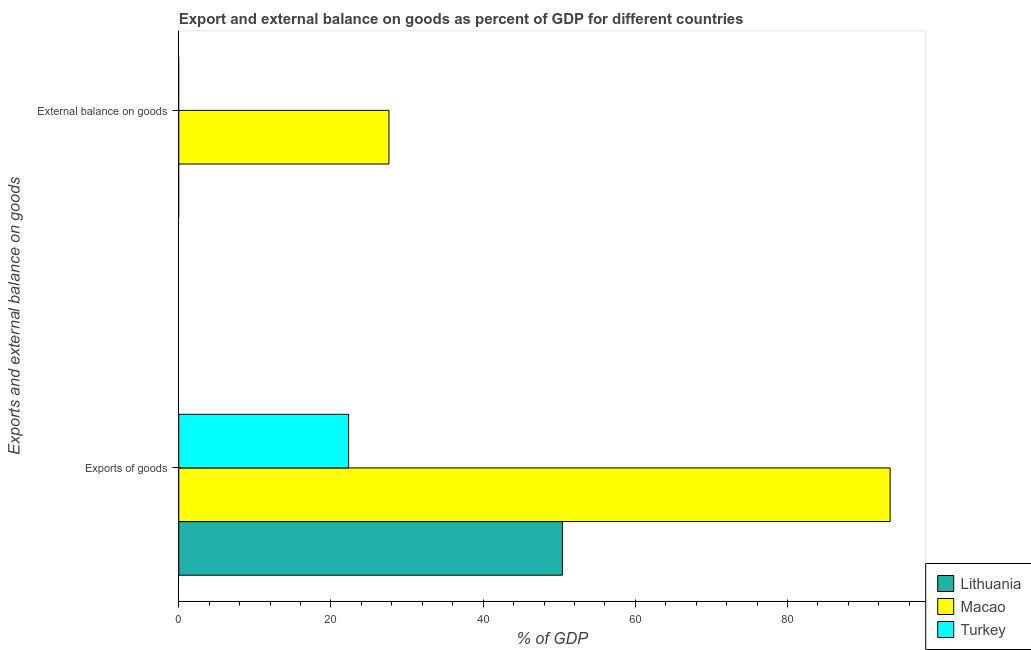Are the number of bars on each tick of the Y-axis equal?
Provide a succinct answer. No. How many bars are there on the 2nd tick from the bottom?
Provide a short and direct response. 1. What is the label of the 1st group of bars from the top?
Your answer should be very brief. External balance on goods. What is the external balance on goods as percentage of gdp in Turkey?
Offer a terse response. 0. Across all countries, what is the maximum export of goods as percentage of gdp?
Keep it short and to the point. 93.49. In which country was the export of goods as percentage of gdp maximum?
Your answer should be very brief. Macao. What is the total external balance on goods as percentage of gdp in the graph?
Offer a terse response. 27.62. What is the difference between the export of goods as percentage of gdp in Macao and that in Lithuania?
Keep it short and to the point. 43.07. What is the difference between the external balance on goods as percentage of gdp in Macao and the export of goods as percentage of gdp in Lithuania?
Give a very brief answer. -22.8. What is the average external balance on goods as percentage of gdp per country?
Your answer should be compact. 9.21. What is the difference between the export of goods as percentage of gdp and external balance on goods as percentage of gdp in Macao?
Make the answer very short. 65.87. What is the ratio of the export of goods as percentage of gdp in Turkey to that in Macao?
Give a very brief answer. 0.24. Are all the bars in the graph horizontal?
Your answer should be compact. Yes. How many countries are there in the graph?
Make the answer very short. 3. Are the values on the major ticks of X-axis written in scientific E-notation?
Offer a very short reply. No. Does the graph contain any zero values?
Keep it short and to the point. Yes. Where does the legend appear in the graph?
Provide a short and direct response. Bottom right. How are the legend labels stacked?
Make the answer very short. Vertical. What is the title of the graph?
Keep it short and to the point. Export and external balance on goods as percent of GDP for different countries. Does "Guinea" appear as one of the legend labels in the graph?
Provide a short and direct response. No. What is the label or title of the X-axis?
Provide a succinct answer. % of GDP. What is the label or title of the Y-axis?
Make the answer very short. Exports and external balance on goods. What is the % of GDP of Lithuania in Exports of goods?
Keep it short and to the point. 50.42. What is the % of GDP in Macao in Exports of goods?
Give a very brief answer. 93.49. What is the % of GDP in Turkey in Exports of goods?
Ensure brevity in your answer.  22.32. What is the % of GDP in Macao in External balance on goods?
Offer a very short reply. 27.62. What is the % of GDP of Turkey in External balance on goods?
Your response must be concise. 0. Across all Exports and external balance on goods, what is the maximum % of GDP in Lithuania?
Ensure brevity in your answer.  50.42. Across all Exports and external balance on goods, what is the maximum % of GDP in Macao?
Your answer should be compact. 93.49. Across all Exports and external balance on goods, what is the maximum % of GDP of Turkey?
Your response must be concise. 22.32. Across all Exports and external balance on goods, what is the minimum % of GDP of Macao?
Offer a terse response. 27.62. What is the total % of GDP of Lithuania in the graph?
Provide a short and direct response. 50.42. What is the total % of GDP of Macao in the graph?
Keep it short and to the point. 121.11. What is the total % of GDP in Turkey in the graph?
Keep it short and to the point. 22.32. What is the difference between the % of GDP in Macao in Exports of goods and that in External balance on goods?
Ensure brevity in your answer.  65.87. What is the difference between the % of GDP in Lithuania in Exports of goods and the % of GDP in Macao in External balance on goods?
Offer a very short reply. 22.8. What is the average % of GDP in Lithuania per Exports and external balance on goods?
Your response must be concise. 25.21. What is the average % of GDP in Macao per Exports and external balance on goods?
Provide a short and direct response. 60.55. What is the average % of GDP of Turkey per Exports and external balance on goods?
Your response must be concise. 11.16. What is the difference between the % of GDP in Lithuania and % of GDP in Macao in Exports of goods?
Your response must be concise. -43.07. What is the difference between the % of GDP of Lithuania and % of GDP of Turkey in Exports of goods?
Your response must be concise. 28.09. What is the difference between the % of GDP of Macao and % of GDP of Turkey in Exports of goods?
Give a very brief answer. 71.17. What is the ratio of the % of GDP in Macao in Exports of goods to that in External balance on goods?
Keep it short and to the point. 3.38. What is the difference between the highest and the second highest % of GDP of Macao?
Offer a very short reply. 65.87. What is the difference between the highest and the lowest % of GDP in Lithuania?
Provide a succinct answer. 50.42. What is the difference between the highest and the lowest % of GDP of Macao?
Your answer should be compact. 65.87. What is the difference between the highest and the lowest % of GDP in Turkey?
Provide a short and direct response. 22.32. 